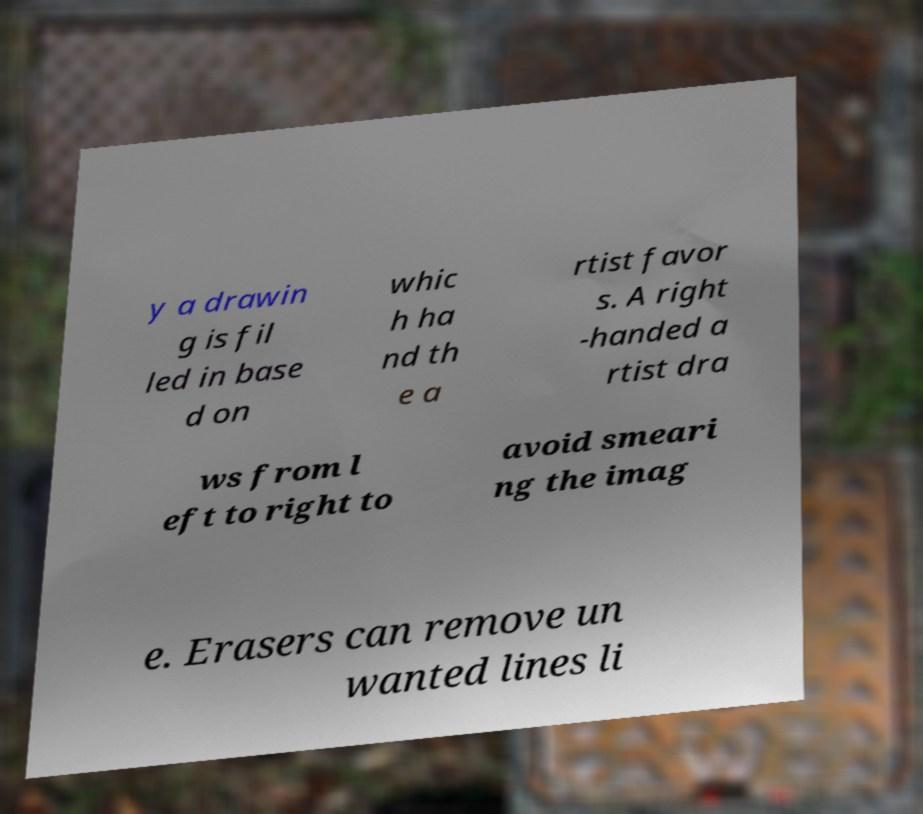Please identify and transcribe the text found in this image. y a drawin g is fil led in base d on whic h ha nd th e a rtist favor s. A right -handed a rtist dra ws from l eft to right to avoid smeari ng the imag e. Erasers can remove un wanted lines li 